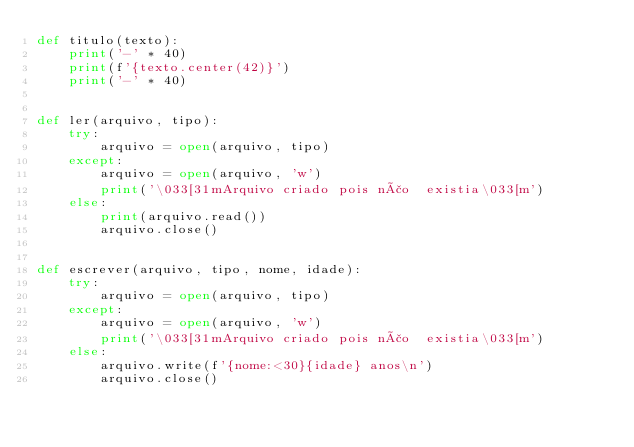<code> <loc_0><loc_0><loc_500><loc_500><_Python_>def titulo(texto):
    print('-' * 40)
    print(f'{texto.center(42)}')
    print('-' * 40)


def ler(arquivo, tipo):
    try:
        arquivo = open(arquivo, tipo)
    except:
        arquivo = open(arquivo, 'w')
        print('\033[31mArquivo criado pois não  existia\033[m')
    else:
        print(arquivo.read())
        arquivo.close()


def escrever(arquivo, tipo, nome, idade):
    try:
        arquivo = open(arquivo, tipo)
    except:
        arquivo = open(arquivo, 'w')
        print('\033[31mArquivo criado pois não  existia\033[m')
    else:
        arquivo.write(f'{nome:<30}{idade} anos\n')
        arquivo.close()
</code> 